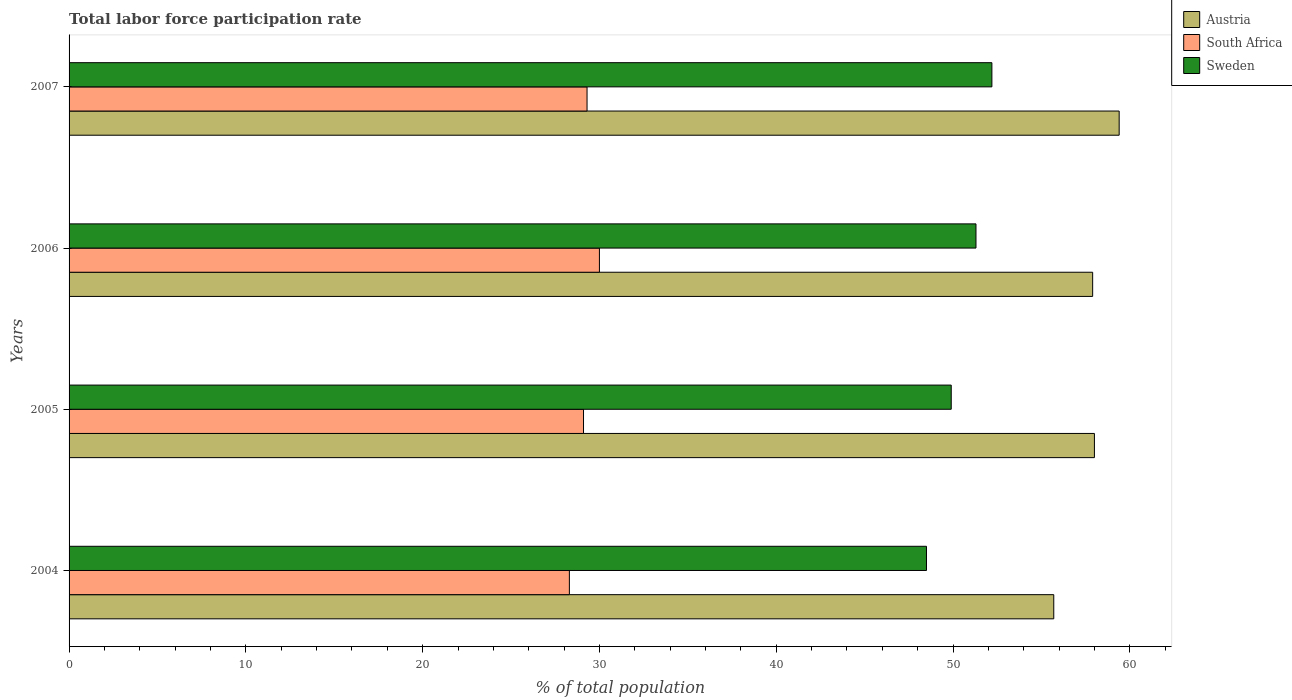How many different coloured bars are there?
Your response must be concise. 3. How many groups of bars are there?
Give a very brief answer. 4. How many bars are there on the 2nd tick from the bottom?
Provide a succinct answer. 3. In how many cases, is the number of bars for a given year not equal to the number of legend labels?
Make the answer very short. 0. What is the total labor force participation rate in South Africa in 2007?
Ensure brevity in your answer.  29.3. Across all years, what is the maximum total labor force participation rate in Sweden?
Your answer should be very brief. 52.2. Across all years, what is the minimum total labor force participation rate in Austria?
Your answer should be very brief. 55.7. In which year was the total labor force participation rate in Sweden maximum?
Offer a very short reply. 2007. What is the total total labor force participation rate in Sweden in the graph?
Give a very brief answer. 201.9. What is the difference between the total labor force participation rate in South Africa in 2006 and that in 2007?
Give a very brief answer. 0.7. What is the difference between the total labor force participation rate in Austria in 2004 and the total labor force participation rate in South Africa in 2007?
Offer a terse response. 26.4. What is the average total labor force participation rate in Sweden per year?
Give a very brief answer. 50.48. In the year 2004, what is the difference between the total labor force participation rate in South Africa and total labor force participation rate in Sweden?
Keep it short and to the point. -20.2. What is the ratio of the total labor force participation rate in Austria in 2005 to that in 2006?
Your answer should be very brief. 1. What is the difference between the highest and the second highest total labor force participation rate in Austria?
Your response must be concise. 1.4. What is the difference between the highest and the lowest total labor force participation rate in Sweden?
Offer a terse response. 3.7. In how many years, is the total labor force participation rate in South Africa greater than the average total labor force participation rate in South Africa taken over all years?
Your answer should be very brief. 2. Is the sum of the total labor force participation rate in Austria in 2004 and 2005 greater than the maximum total labor force participation rate in South Africa across all years?
Ensure brevity in your answer.  Yes. What does the 3rd bar from the bottom in 2005 represents?
Your answer should be compact. Sweden. Are all the bars in the graph horizontal?
Give a very brief answer. Yes. How many years are there in the graph?
Your response must be concise. 4. Does the graph contain any zero values?
Ensure brevity in your answer.  No. Where does the legend appear in the graph?
Your answer should be compact. Top right. How many legend labels are there?
Keep it short and to the point. 3. How are the legend labels stacked?
Your response must be concise. Vertical. What is the title of the graph?
Offer a very short reply. Total labor force participation rate. Does "New Zealand" appear as one of the legend labels in the graph?
Offer a terse response. No. What is the label or title of the X-axis?
Offer a terse response. % of total population. What is the label or title of the Y-axis?
Make the answer very short. Years. What is the % of total population in Austria in 2004?
Provide a short and direct response. 55.7. What is the % of total population in South Africa in 2004?
Provide a short and direct response. 28.3. What is the % of total population of Sweden in 2004?
Provide a short and direct response. 48.5. What is the % of total population of Austria in 2005?
Ensure brevity in your answer.  58. What is the % of total population of South Africa in 2005?
Make the answer very short. 29.1. What is the % of total population in Sweden in 2005?
Provide a short and direct response. 49.9. What is the % of total population of Austria in 2006?
Your answer should be very brief. 57.9. What is the % of total population in Sweden in 2006?
Offer a very short reply. 51.3. What is the % of total population of Austria in 2007?
Ensure brevity in your answer.  59.4. What is the % of total population of South Africa in 2007?
Provide a short and direct response. 29.3. What is the % of total population in Sweden in 2007?
Make the answer very short. 52.2. Across all years, what is the maximum % of total population of Austria?
Give a very brief answer. 59.4. Across all years, what is the maximum % of total population in South Africa?
Offer a terse response. 30. Across all years, what is the maximum % of total population in Sweden?
Give a very brief answer. 52.2. Across all years, what is the minimum % of total population in Austria?
Your answer should be very brief. 55.7. Across all years, what is the minimum % of total population of South Africa?
Your response must be concise. 28.3. Across all years, what is the minimum % of total population of Sweden?
Keep it short and to the point. 48.5. What is the total % of total population in Austria in the graph?
Provide a succinct answer. 231. What is the total % of total population in South Africa in the graph?
Offer a very short reply. 116.7. What is the total % of total population of Sweden in the graph?
Provide a succinct answer. 201.9. What is the difference between the % of total population in Austria in 2004 and that in 2005?
Offer a very short reply. -2.3. What is the difference between the % of total population of Sweden in 2004 and that in 2005?
Your answer should be compact. -1.4. What is the difference between the % of total population of South Africa in 2004 and that in 2006?
Ensure brevity in your answer.  -1.7. What is the difference between the % of total population in Sweden in 2005 and that in 2006?
Keep it short and to the point. -1.4. What is the difference between the % of total population in Sweden in 2005 and that in 2007?
Ensure brevity in your answer.  -2.3. What is the difference between the % of total population of Austria in 2004 and the % of total population of South Africa in 2005?
Provide a succinct answer. 26.6. What is the difference between the % of total population of Austria in 2004 and the % of total population of Sweden in 2005?
Your answer should be very brief. 5.8. What is the difference between the % of total population of South Africa in 2004 and the % of total population of Sweden in 2005?
Your response must be concise. -21.6. What is the difference between the % of total population of Austria in 2004 and the % of total population of South Africa in 2006?
Ensure brevity in your answer.  25.7. What is the difference between the % of total population of Austria in 2004 and the % of total population of Sweden in 2006?
Your answer should be very brief. 4.4. What is the difference between the % of total population in South Africa in 2004 and the % of total population in Sweden in 2006?
Your answer should be compact. -23. What is the difference between the % of total population in Austria in 2004 and the % of total population in South Africa in 2007?
Keep it short and to the point. 26.4. What is the difference between the % of total population of South Africa in 2004 and the % of total population of Sweden in 2007?
Your response must be concise. -23.9. What is the difference between the % of total population of Austria in 2005 and the % of total population of South Africa in 2006?
Your answer should be compact. 28. What is the difference between the % of total population of Austria in 2005 and the % of total population of Sweden in 2006?
Your answer should be compact. 6.7. What is the difference between the % of total population of South Africa in 2005 and the % of total population of Sweden in 2006?
Provide a short and direct response. -22.2. What is the difference between the % of total population in Austria in 2005 and the % of total population in South Africa in 2007?
Make the answer very short. 28.7. What is the difference between the % of total population in Austria in 2005 and the % of total population in Sweden in 2007?
Offer a terse response. 5.8. What is the difference between the % of total population of South Africa in 2005 and the % of total population of Sweden in 2007?
Keep it short and to the point. -23.1. What is the difference between the % of total population in Austria in 2006 and the % of total population in South Africa in 2007?
Provide a short and direct response. 28.6. What is the difference between the % of total population of South Africa in 2006 and the % of total population of Sweden in 2007?
Offer a very short reply. -22.2. What is the average % of total population in Austria per year?
Your response must be concise. 57.75. What is the average % of total population in South Africa per year?
Your answer should be compact. 29.18. What is the average % of total population of Sweden per year?
Your response must be concise. 50.48. In the year 2004, what is the difference between the % of total population of Austria and % of total population of South Africa?
Provide a short and direct response. 27.4. In the year 2004, what is the difference between the % of total population of South Africa and % of total population of Sweden?
Ensure brevity in your answer.  -20.2. In the year 2005, what is the difference between the % of total population in Austria and % of total population in South Africa?
Provide a succinct answer. 28.9. In the year 2005, what is the difference between the % of total population in Austria and % of total population in Sweden?
Your response must be concise. 8.1. In the year 2005, what is the difference between the % of total population in South Africa and % of total population in Sweden?
Give a very brief answer. -20.8. In the year 2006, what is the difference between the % of total population in Austria and % of total population in South Africa?
Provide a short and direct response. 27.9. In the year 2006, what is the difference between the % of total population of Austria and % of total population of Sweden?
Your answer should be very brief. 6.6. In the year 2006, what is the difference between the % of total population of South Africa and % of total population of Sweden?
Ensure brevity in your answer.  -21.3. In the year 2007, what is the difference between the % of total population in Austria and % of total population in South Africa?
Offer a very short reply. 30.1. In the year 2007, what is the difference between the % of total population in South Africa and % of total population in Sweden?
Offer a terse response. -22.9. What is the ratio of the % of total population of Austria in 2004 to that in 2005?
Make the answer very short. 0.96. What is the ratio of the % of total population of South Africa in 2004 to that in 2005?
Provide a succinct answer. 0.97. What is the ratio of the % of total population of Sweden in 2004 to that in 2005?
Provide a short and direct response. 0.97. What is the ratio of the % of total population in South Africa in 2004 to that in 2006?
Provide a short and direct response. 0.94. What is the ratio of the % of total population of Sweden in 2004 to that in 2006?
Keep it short and to the point. 0.95. What is the ratio of the % of total population of Austria in 2004 to that in 2007?
Provide a succinct answer. 0.94. What is the ratio of the % of total population in South Africa in 2004 to that in 2007?
Offer a terse response. 0.97. What is the ratio of the % of total population of Sweden in 2004 to that in 2007?
Ensure brevity in your answer.  0.93. What is the ratio of the % of total population in Austria in 2005 to that in 2006?
Your answer should be compact. 1. What is the ratio of the % of total population of Sweden in 2005 to that in 2006?
Provide a succinct answer. 0.97. What is the ratio of the % of total population in Austria in 2005 to that in 2007?
Provide a short and direct response. 0.98. What is the ratio of the % of total population of Sweden in 2005 to that in 2007?
Offer a very short reply. 0.96. What is the ratio of the % of total population in Austria in 2006 to that in 2007?
Make the answer very short. 0.97. What is the ratio of the % of total population of South Africa in 2006 to that in 2007?
Provide a succinct answer. 1.02. What is the ratio of the % of total population of Sweden in 2006 to that in 2007?
Your response must be concise. 0.98. What is the difference between the highest and the second highest % of total population in Sweden?
Provide a short and direct response. 0.9. What is the difference between the highest and the lowest % of total population in Sweden?
Provide a succinct answer. 3.7. 